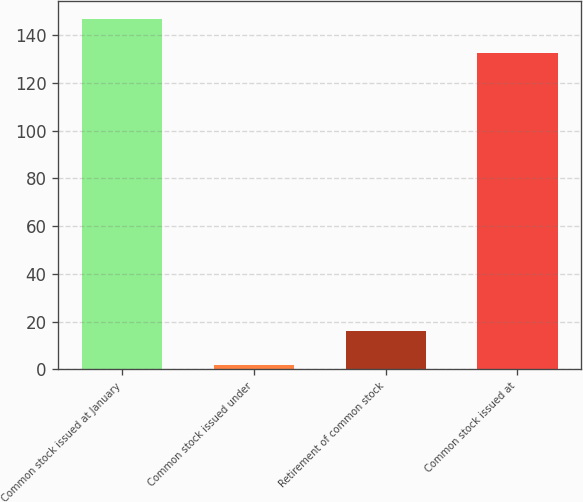Convert chart to OTSL. <chart><loc_0><loc_0><loc_500><loc_500><bar_chart><fcel>Common stock issued at January<fcel>Common stock issued under<fcel>Retirement of common stock<fcel>Common stock issued at<nl><fcel>146.88<fcel>2<fcel>16.18<fcel>132.7<nl></chart> 